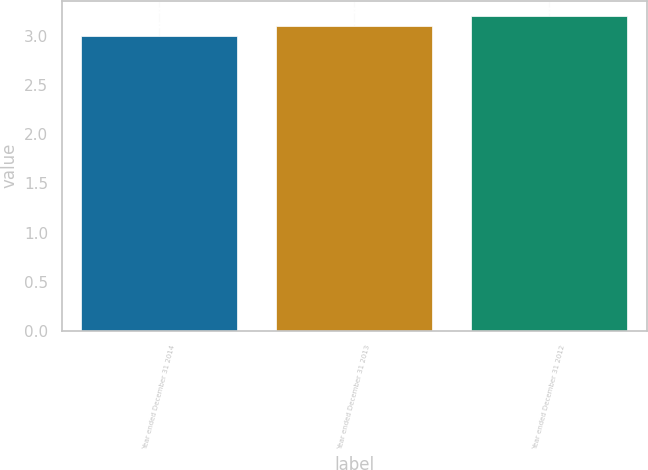Convert chart to OTSL. <chart><loc_0><loc_0><loc_500><loc_500><bar_chart><fcel>Year ended December 31 2014<fcel>Year ended December 31 2013<fcel>Year ended December 31 2012<nl><fcel>3<fcel>3.1<fcel>3.2<nl></chart> 